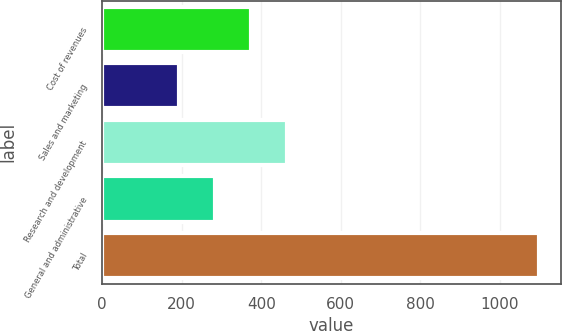Convert chart. <chart><loc_0><loc_0><loc_500><loc_500><bar_chart><fcel>Cost of revenues<fcel>Sales and marketing<fcel>Research and development<fcel>General and administrative<fcel>Total<nl><fcel>375<fcel>194<fcel>465.5<fcel>284.5<fcel>1099<nl></chart> 